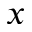Convert formula to latex. <formula><loc_0><loc_0><loc_500><loc_500>x</formula> 